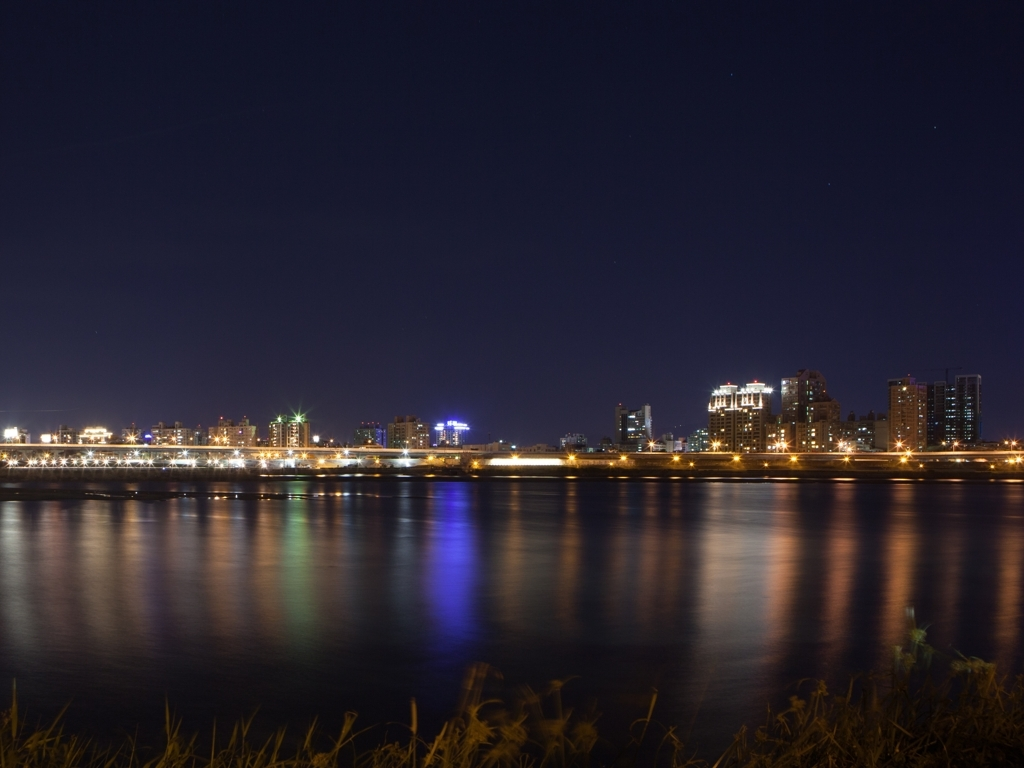How might the time of day affect the mood of this picture? The time of day, being nighttime, imbues the picture with a peaceful and quiet mood, as opposed to the hustle and bustle one would expect during the day. The illuminated skyline against the dark sky can also convey a sense of livelihood and activity that persists through the night. 